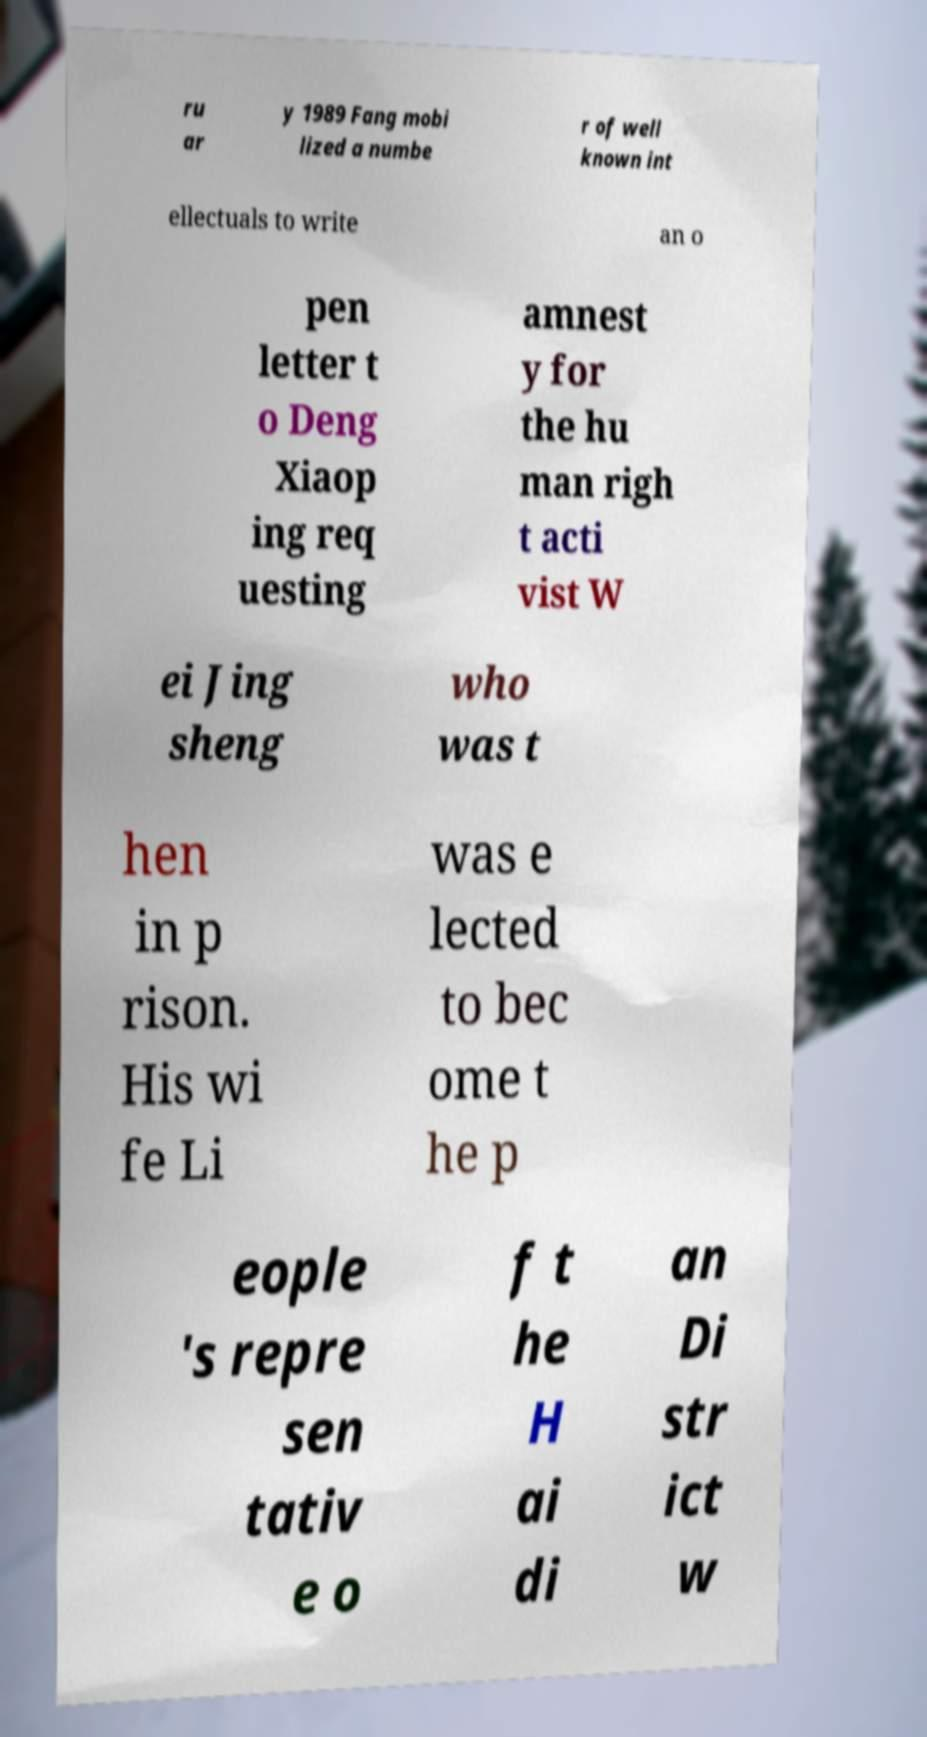Could you assist in decoding the text presented in this image and type it out clearly? ru ar y 1989 Fang mobi lized a numbe r of well known int ellectuals to write an o pen letter t o Deng Xiaop ing req uesting amnest y for the hu man righ t acti vist W ei Jing sheng who was t hen in p rison. His wi fe Li was e lected to bec ome t he p eople 's repre sen tativ e o f t he H ai di an Di str ict w 